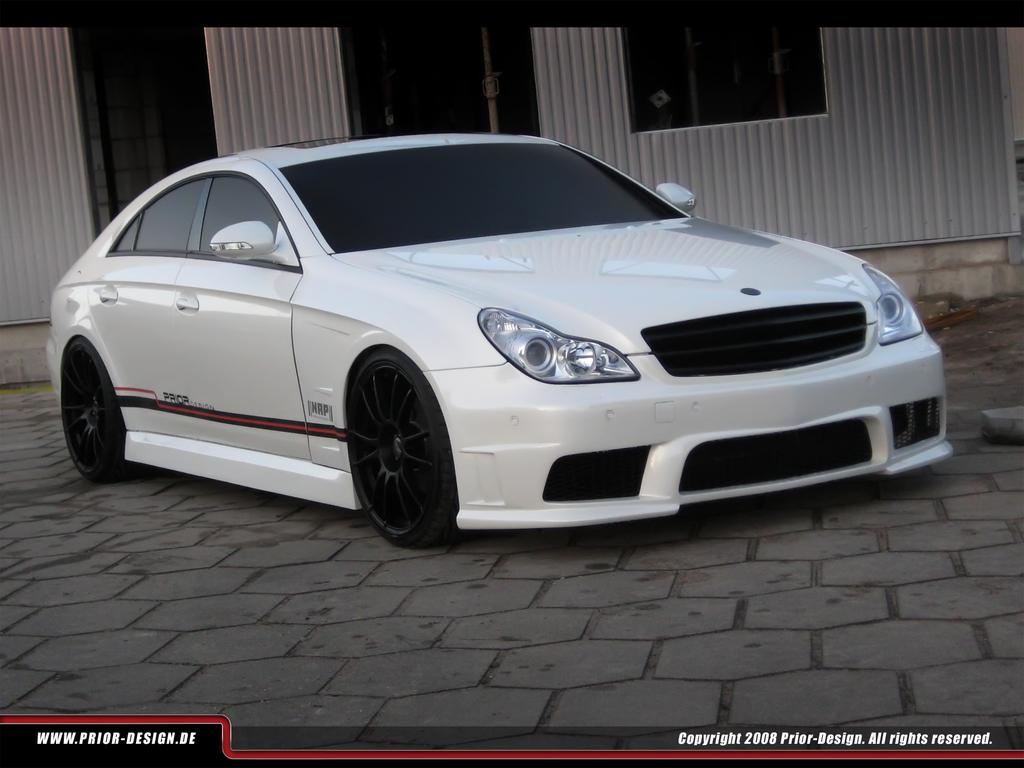What is the main subject of the picture? The main subject of the picture is a car. What can be seen in the background of the picture? There appears to be a house in the background of the picture. Can you describe any additional features of the image? The image has watermarks. What type of furniture can be seen in the car in the image? There is no furniture visible inside the car in the image. How many seeds are present in the image? There are no seeds present in the image. 